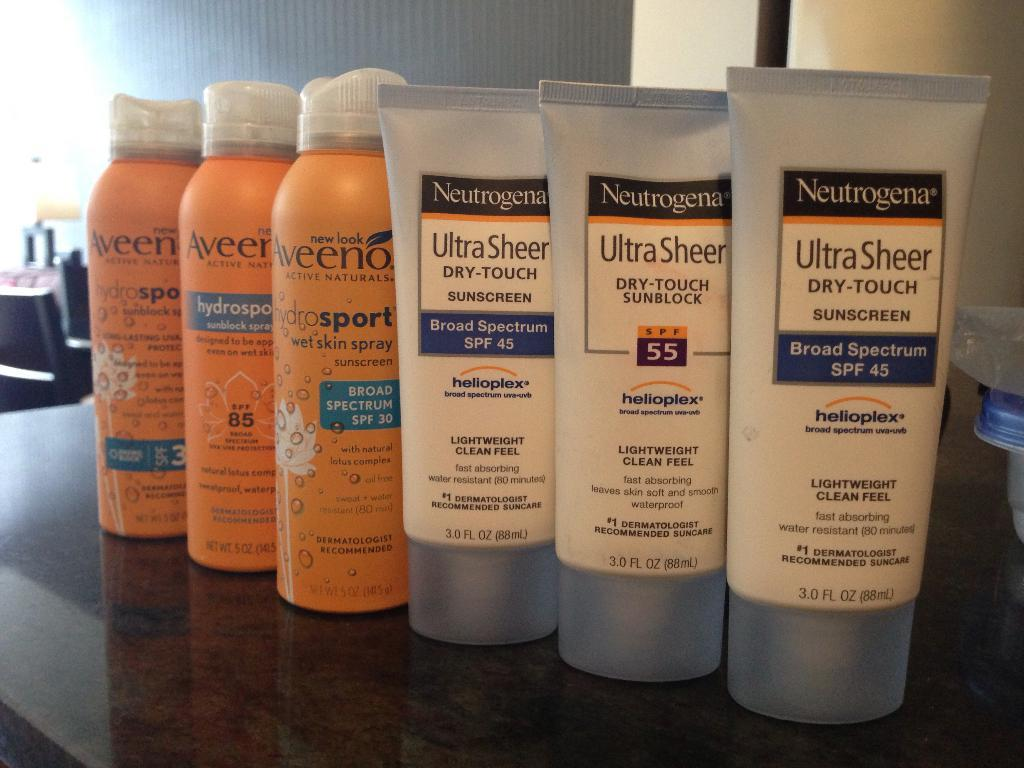Provide a one-sentence caption for the provided image. the words ultra sheer are on some items. 